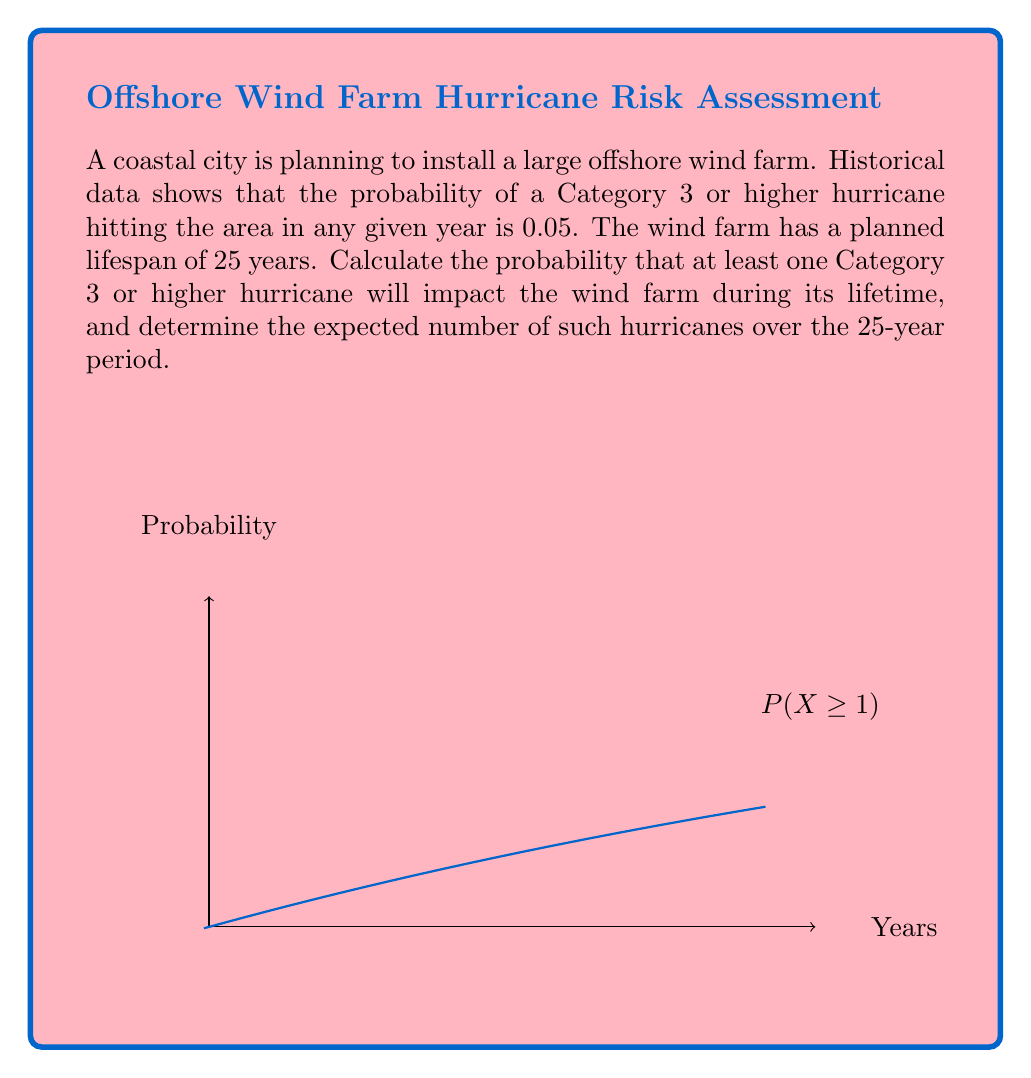What is the answer to this math problem? Let's approach this problem step-by-step:

1) First, we need to calculate the probability of at least one hurricane occurring in 25 years.

2) It's easier to calculate the probability of no hurricanes occurring and then subtract from 1.

3) The probability of no hurricane in one year is 1 - 0.05 = 0.95.

4) For no hurricanes in 25 years, we need this to happen 25 times in a row. So:

   $P(\text{no hurricanes in 25 years}) = 0.95^{25}$

5) Therefore, the probability of at least one hurricane in 25 years is:

   $P(\text{at least one hurricane}) = 1 - 0.95^{25}$

6) Calculating this:
   $1 - 0.95^{25} \approx 0.7226$ or about 72.26%

7) For the expected number of hurricanes, we can use the property of expectation:
   $E(X) = n * p$, where n is the number of trials and p is the probability of success.

8) In this case, $n = 25$ (years) and $p = 0.05$ (probability of hurricane per year)

9) So, $E(X) = 25 * 0.05 = 1.25$

Therefore, the probability of at least one Category 3 or higher hurricane impacting the wind farm during its 25-year lifespan is approximately 72.26%, and the expected number of such hurricanes over this period is 1.25.
Answer: Probability: 72.26%; Expected number: 1.25 hurricanes 